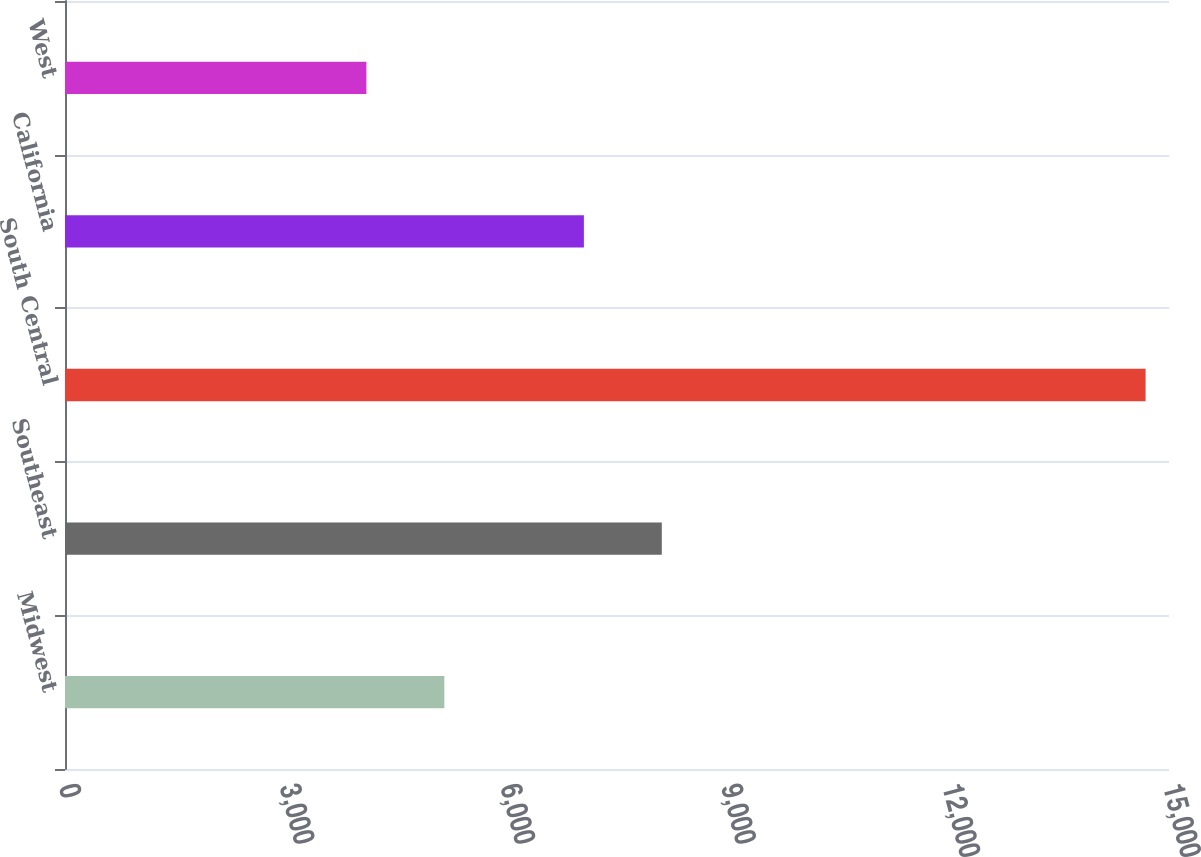<chart> <loc_0><loc_0><loc_500><loc_500><bar_chart><fcel>Midwest<fcel>Southeast<fcel>South Central<fcel>California<fcel>West<nl><fcel>5153.7<fcel>8108.7<fcel>14682<fcel>7050<fcel>4095<nl></chart> 